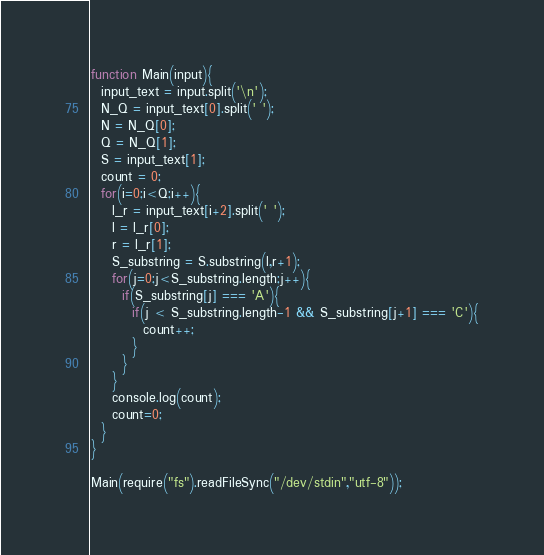Convert code to text. <code><loc_0><loc_0><loc_500><loc_500><_JavaScript_>function Main(input){
  input_text = input.split('\n');
  N_Q = input_text[0].split(' ');
  N = N_Q[0];
  Q = N_Q[1];
  S = input_text[1];
  count = 0;
  for(i=0;i<Q;i++){
    l_r = input_text[i+2].split(' ');
    l = l_r[0];
    r = l_r[1];
    S_substring = S.substring(l,r+1);
    for(j=0;j<S_substring.length;j++){
      if(S_substring[j] === 'A'){
        if(j < S_substring.length-1 && S_substring[j+1] === 'C'){
          count++;
        }
      }
    }
    console.log(count);
    count=0;
  }
}
 
Main(require("fs").readFileSync("/dev/stdin","utf-8"));
</code> 